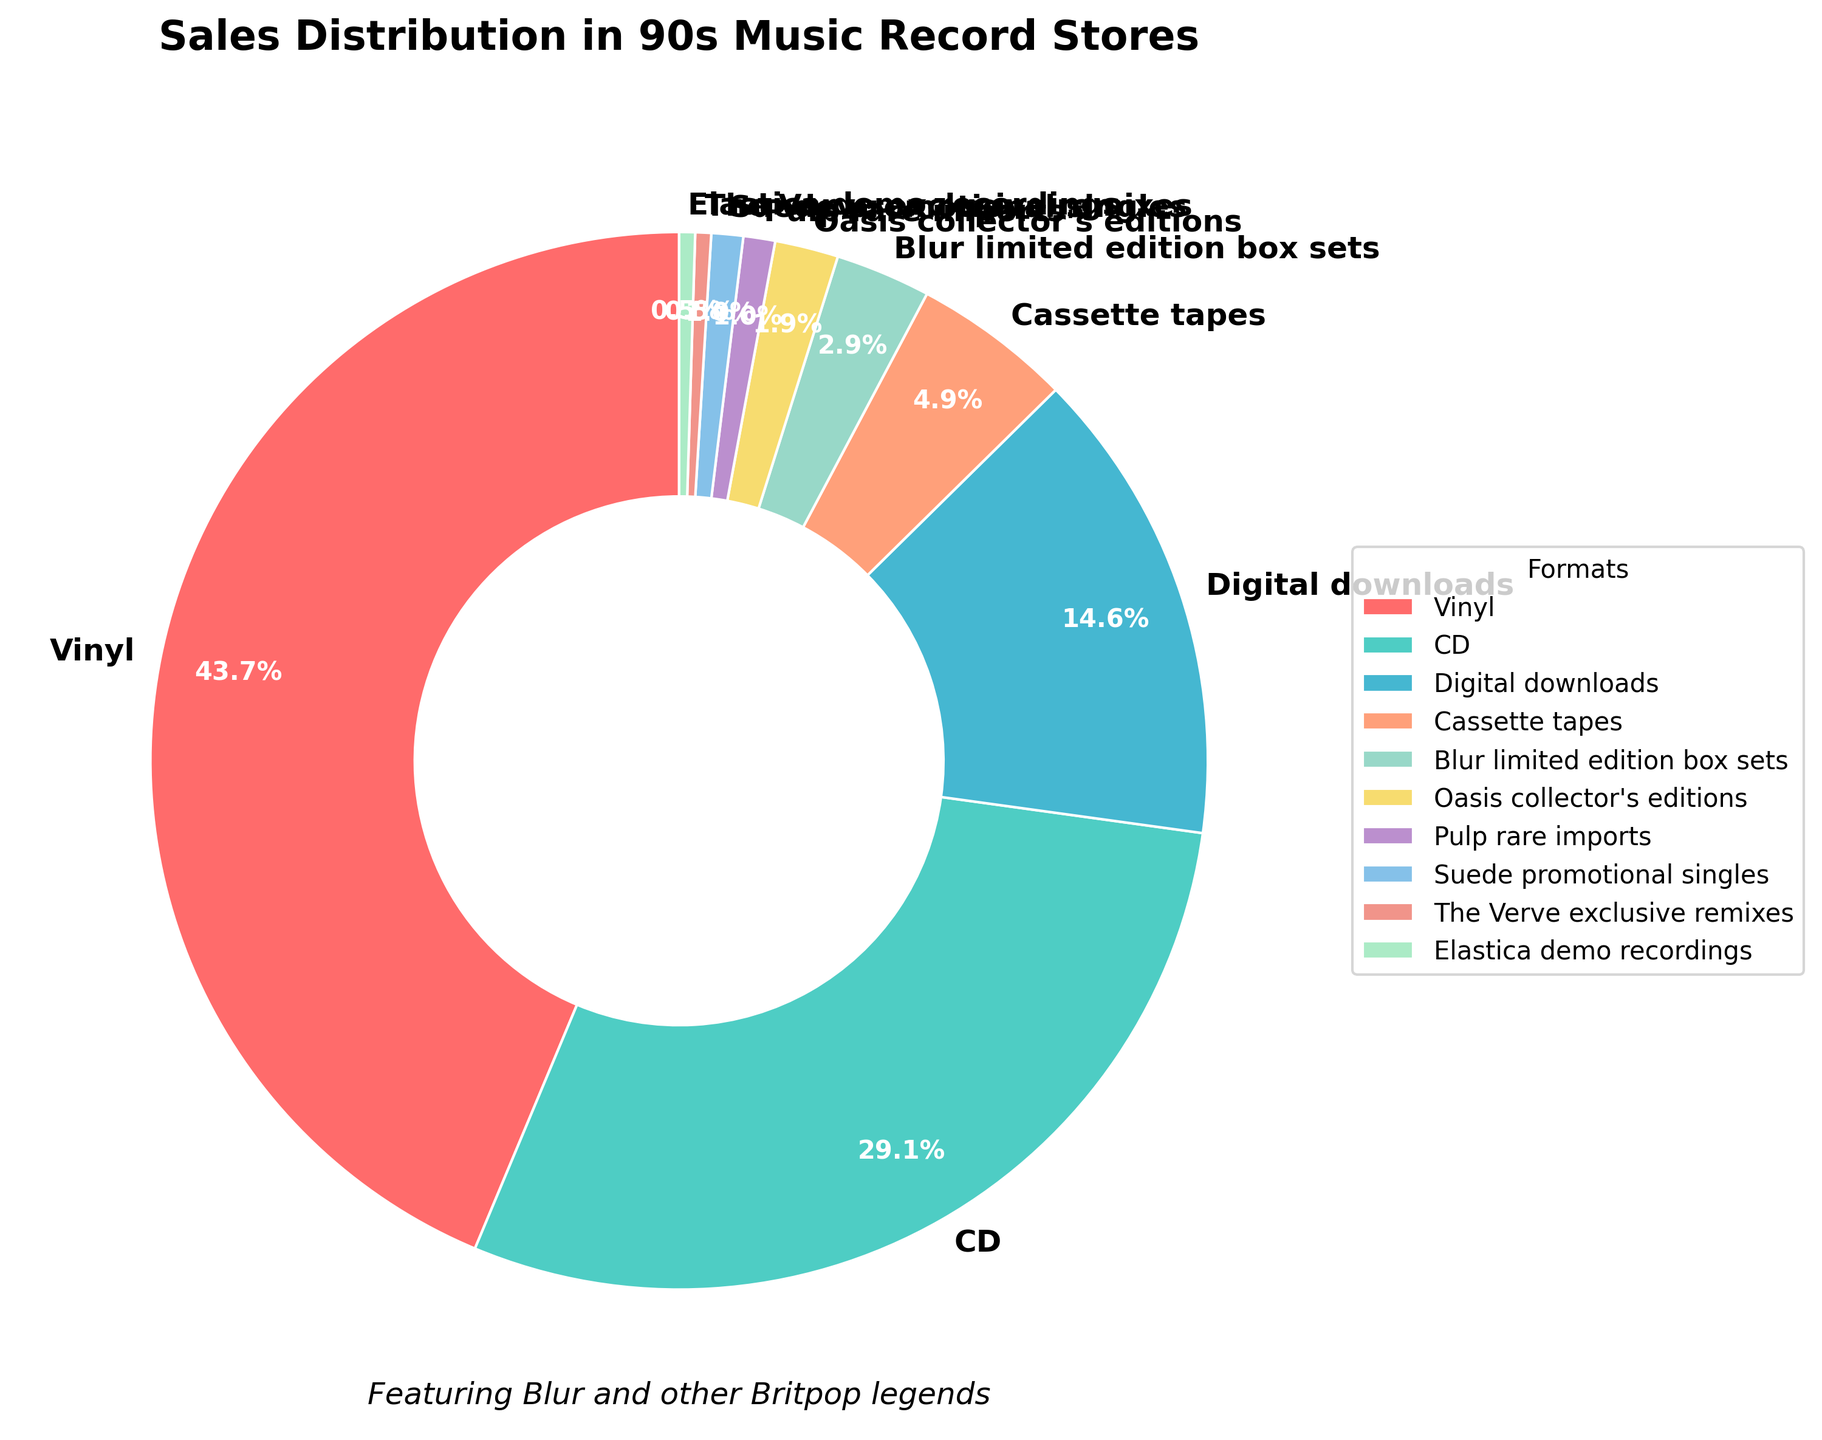What's the largest segment in the pie chart? Looking at the pie chart, the largest segment is the one that takes up the most space. This segment represents vinyl, with 45% of the sales.
Answer: Vinyl, 45% Which two formats combined account for more than half of the sales? To find out which two formats together make up more than half of the sales, we add their percentages. Vinyl is 45%, and CD is 30%. When added together, their total is 75%, which is more than half.
Answer: Vinyl and CD What is the difference in percentage between CD and digital downloads? To find the difference, subtract the percentage for digital downloads from the percentage for CDs. CD is 30% and digital downloads is 15%. The difference is 30% - 15% = 15%.
Answer: 15% How many formats each have less than 5% of the sales? The formats with less than 5% of the sales are Cassette tapes, Blur limited edition box sets, Oasis collector's editions, Pulp rare imports, Suede promotional singles, The Verve exclusive remixes, and Elastica demo recordings. Counting these, there are 7 formats.
Answer: 7 What is the combined percentage of the least represented formats? The least represented formats (those with less than 5% each) are as follows: Cassette tapes (5%), Blur limited edition box sets (3%), Oasis collector's editions (2%), Pulp rare imports (1%), Suede promotional singles (1%), The Verve exclusive remixes (0.5%), and Elastica demo recordings (0.5%). Adding these together: 5% + 3% + 2% + 1% + 1% + 0.5% + 0.5% = 13%.
Answer: 13% Which color represents the CD segment? Referring to the pie chart's legend and color coding, the CD segment is represented by the second color in the custom color list, which is a lighter shade of green or teal.
Answer: Teal Which has a greater percentage: cassette tapes or all collector's editions combined? Cassette tapes have 5%. The collector's editions are Blur limited edition box sets (3%) and Oasis collector's editions (2%), which together sum up to 3% + 2% = 5%. Therefore, the percentage is equal.
Answer: Equal How much more popular are vinyl sales compared to Blur limited edition box sets? Vinyl has 45% and Blur limited edition box sets have 3%. The difference is calculated by subtracting 3% from 45%, which results in 42%.
Answer: 42% What visual feature makes the vinyl segment stand out in the pie chart? In the pie chart, the vinyl segment stands out as the largest wedge, occupying the most space among all other formats. Moreover, it is represented by a prominent red color, making it visually striking.
Answer: Largest wedge and prominent color 